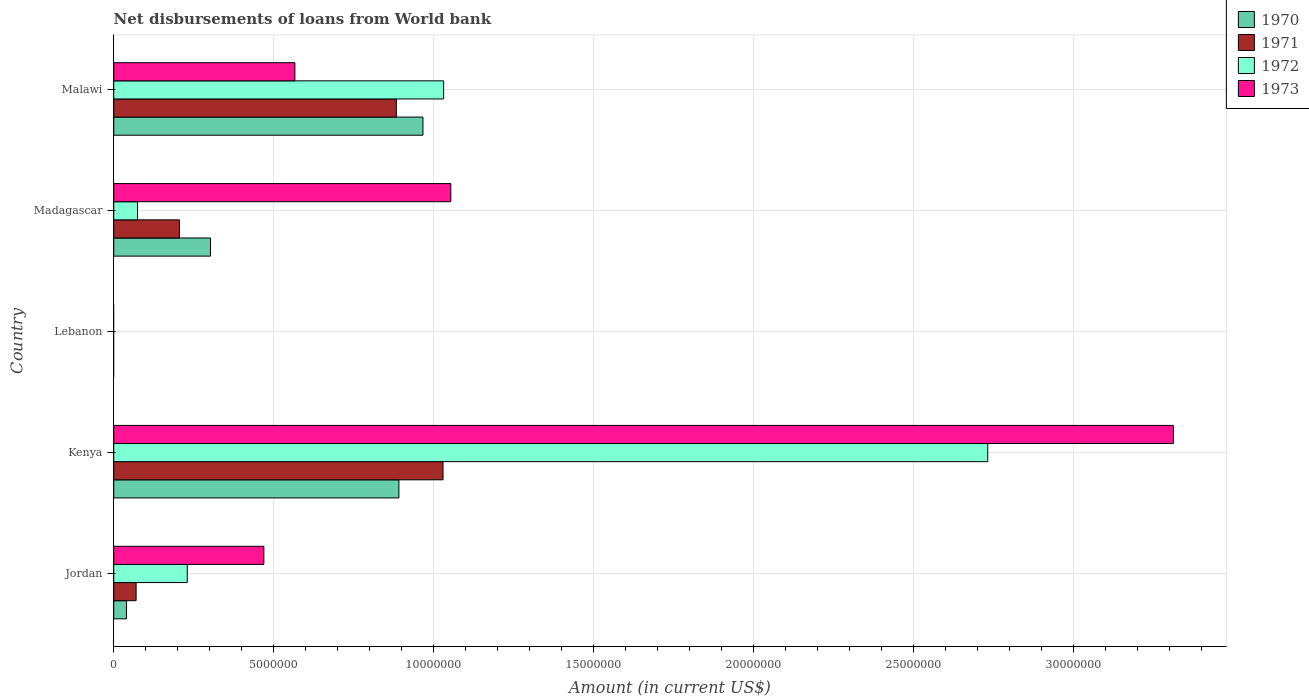How many different coloured bars are there?
Give a very brief answer. 4. How many bars are there on the 5th tick from the bottom?
Provide a succinct answer. 4. What is the label of the 1st group of bars from the top?
Offer a terse response. Malawi. What is the amount of loan disbursed from World Bank in 1971 in Madagascar?
Offer a terse response. 2.05e+06. Across all countries, what is the maximum amount of loan disbursed from World Bank in 1970?
Provide a succinct answer. 9.66e+06. In which country was the amount of loan disbursed from World Bank in 1973 maximum?
Keep it short and to the point. Kenya. What is the total amount of loan disbursed from World Bank in 1970 in the graph?
Offer a terse response. 2.20e+07. What is the difference between the amount of loan disbursed from World Bank in 1970 in Kenya and that in Madagascar?
Offer a terse response. 5.89e+06. What is the difference between the amount of loan disbursed from World Bank in 1973 in Kenya and the amount of loan disbursed from World Bank in 1970 in Madagascar?
Offer a terse response. 3.01e+07. What is the average amount of loan disbursed from World Bank in 1973 per country?
Your answer should be compact. 1.08e+07. What is the difference between the amount of loan disbursed from World Bank in 1970 and amount of loan disbursed from World Bank in 1971 in Kenya?
Provide a short and direct response. -1.38e+06. What is the ratio of the amount of loan disbursed from World Bank in 1973 in Jordan to that in Kenya?
Provide a succinct answer. 0.14. Is the amount of loan disbursed from World Bank in 1973 in Jordan less than that in Madagascar?
Ensure brevity in your answer.  Yes. What is the difference between the highest and the second highest amount of loan disbursed from World Bank in 1971?
Your answer should be very brief. 1.46e+06. What is the difference between the highest and the lowest amount of loan disbursed from World Bank in 1973?
Your answer should be compact. 3.31e+07. Is the sum of the amount of loan disbursed from World Bank in 1972 in Jordan and Malawi greater than the maximum amount of loan disbursed from World Bank in 1971 across all countries?
Offer a very short reply. Yes. Is it the case that in every country, the sum of the amount of loan disbursed from World Bank in 1971 and amount of loan disbursed from World Bank in 1973 is greater than the amount of loan disbursed from World Bank in 1972?
Make the answer very short. No. How many bars are there?
Give a very brief answer. 16. What is the difference between two consecutive major ticks on the X-axis?
Your response must be concise. 5.00e+06. Are the values on the major ticks of X-axis written in scientific E-notation?
Offer a very short reply. No. Does the graph contain grids?
Give a very brief answer. Yes. Where does the legend appear in the graph?
Your answer should be compact. Top right. How many legend labels are there?
Ensure brevity in your answer.  4. What is the title of the graph?
Offer a terse response. Net disbursements of loans from World bank. Does "2004" appear as one of the legend labels in the graph?
Your answer should be very brief. No. What is the label or title of the X-axis?
Provide a short and direct response. Amount (in current US$). What is the Amount (in current US$) in 1970 in Jordan?
Your answer should be compact. 3.99e+05. What is the Amount (in current US$) in 1971 in Jordan?
Offer a very short reply. 6.99e+05. What is the Amount (in current US$) of 1972 in Jordan?
Offer a very short reply. 2.30e+06. What is the Amount (in current US$) of 1973 in Jordan?
Ensure brevity in your answer.  4.69e+06. What is the Amount (in current US$) of 1970 in Kenya?
Your response must be concise. 8.91e+06. What is the Amount (in current US$) in 1971 in Kenya?
Offer a very short reply. 1.03e+07. What is the Amount (in current US$) in 1972 in Kenya?
Provide a succinct answer. 2.73e+07. What is the Amount (in current US$) of 1973 in Kenya?
Your answer should be compact. 3.31e+07. What is the Amount (in current US$) in 1971 in Lebanon?
Your answer should be compact. 0. What is the Amount (in current US$) in 1972 in Lebanon?
Offer a terse response. 0. What is the Amount (in current US$) of 1970 in Madagascar?
Your response must be concise. 3.02e+06. What is the Amount (in current US$) in 1971 in Madagascar?
Your response must be concise. 2.05e+06. What is the Amount (in current US$) of 1972 in Madagascar?
Your response must be concise. 7.44e+05. What is the Amount (in current US$) of 1973 in Madagascar?
Offer a very short reply. 1.05e+07. What is the Amount (in current US$) in 1970 in Malawi?
Provide a short and direct response. 9.66e+06. What is the Amount (in current US$) of 1971 in Malawi?
Make the answer very short. 8.83e+06. What is the Amount (in current US$) of 1972 in Malawi?
Your response must be concise. 1.03e+07. What is the Amount (in current US$) of 1973 in Malawi?
Provide a short and direct response. 5.66e+06. Across all countries, what is the maximum Amount (in current US$) of 1970?
Provide a short and direct response. 9.66e+06. Across all countries, what is the maximum Amount (in current US$) in 1971?
Your answer should be very brief. 1.03e+07. Across all countries, what is the maximum Amount (in current US$) in 1972?
Make the answer very short. 2.73e+07. Across all countries, what is the maximum Amount (in current US$) of 1973?
Keep it short and to the point. 3.31e+07. What is the total Amount (in current US$) of 1970 in the graph?
Your answer should be very brief. 2.20e+07. What is the total Amount (in current US$) in 1971 in the graph?
Offer a terse response. 2.19e+07. What is the total Amount (in current US$) of 1972 in the graph?
Make the answer very short. 4.07e+07. What is the total Amount (in current US$) in 1973 in the graph?
Your answer should be compact. 5.40e+07. What is the difference between the Amount (in current US$) of 1970 in Jordan and that in Kenya?
Provide a succinct answer. -8.51e+06. What is the difference between the Amount (in current US$) of 1971 in Jordan and that in Kenya?
Make the answer very short. -9.59e+06. What is the difference between the Amount (in current US$) of 1972 in Jordan and that in Kenya?
Your answer should be compact. -2.50e+07. What is the difference between the Amount (in current US$) in 1973 in Jordan and that in Kenya?
Offer a very short reply. -2.84e+07. What is the difference between the Amount (in current US$) in 1970 in Jordan and that in Madagascar?
Make the answer very short. -2.62e+06. What is the difference between the Amount (in current US$) of 1971 in Jordan and that in Madagascar?
Make the answer very short. -1.35e+06. What is the difference between the Amount (in current US$) of 1972 in Jordan and that in Madagascar?
Give a very brief answer. 1.55e+06. What is the difference between the Amount (in current US$) in 1973 in Jordan and that in Madagascar?
Make the answer very short. -5.84e+06. What is the difference between the Amount (in current US$) in 1970 in Jordan and that in Malawi?
Your response must be concise. -9.26e+06. What is the difference between the Amount (in current US$) of 1971 in Jordan and that in Malawi?
Make the answer very short. -8.13e+06. What is the difference between the Amount (in current US$) in 1972 in Jordan and that in Malawi?
Provide a short and direct response. -8.01e+06. What is the difference between the Amount (in current US$) in 1973 in Jordan and that in Malawi?
Your response must be concise. -9.69e+05. What is the difference between the Amount (in current US$) in 1970 in Kenya and that in Madagascar?
Your answer should be compact. 5.89e+06. What is the difference between the Amount (in current US$) of 1971 in Kenya and that in Madagascar?
Your answer should be very brief. 8.24e+06. What is the difference between the Amount (in current US$) in 1972 in Kenya and that in Madagascar?
Your response must be concise. 2.66e+07. What is the difference between the Amount (in current US$) in 1973 in Kenya and that in Madagascar?
Make the answer very short. 2.26e+07. What is the difference between the Amount (in current US$) of 1970 in Kenya and that in Malawi?
Your answer should be very brief. -7.51e+05. What is the difference between the Amount (in current US$) in 1971 in Kenya and that in Malawi?
Offer a terse response. 1.46e+06. What is the difference between the Amount (in current US$) of 1972 in Kenya and that in Malawi?
Your response must be concise. 1.70e+07. What is the difference between the Amount (in current US$) of 1973 in Kenya and that in Malawi?
Your answer should be compact. 2.74e+07. What is the difference between the Amount (in current US$) in 1970 in Madagascar and that in Malawi?
Your response must be concise. -6.64e+06. What is the difference between the Amount (in current US$) of 1971 in Madagascar and that in Malawi?
Provide a succinct answer. -6.78e+06. What is the difference between the Amount (in current US$) of 1972 in Madagascar and that in Malawi?
Offer a very short reply. -9.56e+06. What is the difference between the Amount (in current US$) in 1973 in Madagascar and that in Malawi?
Make the answer very short. 4.87e+06. What is the difference between the Amount (in current US$) in 1970 in Jordan and the Amount (in current US$) in 1971 in Kenya?
Offer a very short reply. -9.89e+06. What is the difference between the Amount (in current US$) in 1970 in Jordan and the Amount (in current US$) in 1972 in Kenya?
Provide a succinct answer. -2.69e+07. What is the difference between the Amount (in current US$) in 1970 in Jordan and the Amount (in current US$) in 1973 in Kenya?
Your answer should be very brief. -3.27e+07. What is the difference between the Amount (in current US$) of 1971 in Jordan and the Amount (in current US$) of 1972 in Kenya?
Make the answer very short. -2.66e+07. What is the difference between the Amount (in current US$) of 1971 in Jordan and the Amount (in current US$) of 1973 in Kenya?
Provide a short and direct response. -3.24e+07. What is the difference between the Amount (in current US$) in 1972 in Jordan and the Amount (in current US$) in 1973 in Kenya?
Provide a succinct answer. -3.08e+07. What is the difference between the Amount (in current US$) of 1970 in Jordan and the Amount (in current US$) of 1971 in Madagascar?
Your response must be concise. -1.65e+06. What is the difference between the Amount (in current US$) of 1970 in Jordan and the Amount (in current US$) of 1972 in Madagascar?
Offer a terse response. -3.45e+05. What is the difference between the Amount (in current US$) in 1970 in Jordan and the Amount (in current US$) in 1973 in Madagascar?
Provide a succinct answer. -1.01e+07. What is the difference between the Amount (in current US$) of 1971 in Jordan and the Amount (in current US$) of 1972 in Madagascar?
Provide a succinct answer. -4.50e+04. What is the difference between the Amount (in current US$) of 1971 in Jordan and the Amount (in current US$) of 1973 in Madagascar?
Provide a succinct answer. -9.83e+06. What is the difference between the Amount (in current US$) in 1972 in Jordan and the Amount (in current US$) in 1973 in Madagascar?
Make the answer very short. -8.24e+06. What is the difference between the Amount (in current US$) of 1970 in Jordan and the Amount (in current US$) of 1971 in Malawi?
Give a very brief answer. -8.43e+06. What is the difference between the Amount (in current US$) of 1970 in Jordan and the Amount (in current US$) of 1972 in Malawi?
Provide a succinct answer. -9.91e+06. What is the difference between the Amount (in current US$) in 1970 in Jordan and the Amount (in current US$) in 1973 in Malawi?
Ensure brevity in your answer.  -5.26e+06. What is the difference between the Amount (in current US$) in 1971 in Jordan and the Amount (in current US$) in 1972 in Malawi?
Provide a short and direct response. -9.61e+06. What is the difference between the Amount (in current US$) in 1971 in Jordan and the Amount (in current US$) in 1973 in Malawi?
Provide a short and direct response. -4.96e+06. What is the difference between the Amount (in current US$) of 1972 in Jordan and the Amount (in current US$) of 1973 in Malawi?
Provide a short and direct response. -3.36e+06. What is the difference between the Amount (in current US$) of 1970 in Kenya and the Amount (in current US$) of 1971 in Madagascar?
Provide a short and direct response. 6.86e+06. What is the difference between the Amount (in current US$) in 1970 in Kenya and the Amount (in current US$) in 1972 in Madagascar?
Offer a terse response. 8.17e+06. What is the difference between the Amount (in current US$) in 1970 in Kenya and the Amount (in current US$) in 1973 in Madagascar?
Your response must be concise. -1.62e+06. What is the difference between the Amount (in current US$) in 1971 in Kenya and the Amount (in current US$) in 1972 in Madagascar?
Your answer should be very brief. 9.54e+06. What is the difference between the Amount (in current US$) of 1971 in Kenya and the Amount (in current US$) of 1973 in Madagascar?
Your answer should be very brief. -2.44e+05. What is the difference between the Amount (in current US$) of 1972 in Kenya and the Amount (in current US$) of 1973 in Madagascar?
Provide a succinct answer. 1.68e+07. What is the difference between the Amount (in current US$) of 1970 in Kenya and the Amount (in current US$) of 1972 in Malawi?
Ensure brevity in your answer.  -1.40e+06. What is the difference between the Amount (in current US$) of 1970 in Kenya and the Amount (in current US$) of 1973 in Malawi?
Your answer should be very brief. 3.25e+06. What is the difference between the Amount (in current US$) in 1971 in Kenya and the Amount (in current US$) in 1972 in Malawi?
Provide a succinct answer. -1.90e+04. What is the difference between the Amount (in current US$) in 1971 in Kenya and the Amount (in current US$) in 1973 in Malawi?
Provide a succinct answer. 4.63e+06. What is the difference between the Amount (in current US$) in 1972 in Kenya and the Amount (in current US$) in 1973 in Malawi?
Offer a very short reply. 2.16e+07. What is the difference between the Amount (in current US$) of 1970 in Madagascar and the Amount (in current US$) of 1971 in Malawi?
Ensure brevity in your answer.  -5.81e+06. What is the difference between the Amount (in current US$) in 1970 in Madagascar and the Amount (in current US$) in 1972 in Malawi?
Offer a terse response. -7.28e+06. What is the difference between the Amount (in current US$) of 1970 in Madagascar and the Amount (in current US$) of 1973 in Malawi?
Ensure brevity in your answer.  -2.64e+06. What is the difference between the Amount (in current US$) of 1971 in Madagascar and the Amount (in current US$) of 1972 in Malawi?
Make the answer very short. -8.25e+06. What is the difference between the Amount (in current US$) in 1971 in Madagascar and the Amount (in current US$) in 1973 in Malawi?
Offer a very short reply. -3.61e+06. What is the difference between the Amount (in current US$) of 1972 in Madagascar and the Amount (in current US$) of 1973 in Malawi?
Your response must be concise. -4.92e+06. What is the average Amount (in current US$) of 1970 per country?
Your answer should be very brief. 4.40e+06. What is the average Amount (in current US$) in 1971 per country?
Make the answer very short. 4.37e+06. What is the average Amount (in current US$) in 1972 per country?
Give a very brief answer. 8.13e+06. What is the average Amount (in current US$) in 1973 per country?
Offer a terse response. 1.08e+07. What is the difference between the Amount (in current US$) of 1970 and Amount (in current US$) of 1972 in Jordan?
Give a very brief answer. -1.90e+06. What is the difference between the Amount (in current US$) of 1970 and Amount (in current US$) of 1973 in Jordan?
Your answer should be very brief. -4.29e+06. What is the difference between the Amount (in current US$) of 1971 and Amount (in current US$) of 1972 in Jordan?
Provide a short and direct response. -1.60e+06. What is the difference between the Amount (in current US$) of 1971 and Amount (in current US$) of 1973 in Jordan?
Your response must be concise. -3.99e+06. What is the difference between the Amount (in current US$) of 1972 and Amount (in current US$) of 1973 in Jordan?
Make the answer very short. -2.39e+06. What is the difference between the Amount (in current US$) of 1970 and Amount (in current US$) of 1971 in Kenya?
Keep it short and to the point. -1.38e+06. What is the difference between the Amount (in current US$) in 1970 and Amount (in current US$) in 1972 in Kenya?
Make the answer very short. -1.84e+07. What is the difference between the Amount (in current US$) of 1970 and Amount (in current US$) of 1973 in Kenya?
Give a very brief answer. -2.42e+07. What is the difference between the Amount (in current US$) of 1971 and Amount (in current US$) of 1972 in Kenya?
Give a very brief answer. -1.70e+07. What is the difference between the Amount (in current US$) in 1971 and Amount (in current US$) in 1973 in Kenya?
Offer a terse response. -2.28e+07. What is the difference between the Amount (in current US$) in 1972 and Amount (in current US$) in 1973 in Kenya?
Offer a very short reply. -5.80e+06. What is the difference between the Amount (in current US$) in 1970 and Amount (in current US$) in 1971 in Madagascar?
Your response must be concise. 9.70e+05. What is the difference between the Amount (in current US$) of 1970 and Amount (in current US$) of 1972 in Madagascar?
Keep it short and to the point. 2.28e+06. What is the difference between the Amount (in current US$) in 1970 and Amount (in current US$) in 1973 in Madagascar?
Your response must be concise. -7.51e+06. What is the difference between the Amount (in current US$) of 1971 and Amount (in current US$) of 1972 in Madagascar?
Offer a very short reply. 1.31e+06. What is the difference between the Amount (in current US$) of 1971 and Amount (in current US$) of 1973 in Madagascar?
Your response must be concise. -8.48e+06. What is the difference between the Amount (in current US$) of 1972 and Amount (in current US$) of 1973 in Madagascar?
Ensure brevity in your answer.  -9.79e+06. What is the difference between the Amount (in current US$) in 1970 and Amount (in current US$) in 1971 in Malawi?
Your answer should be very brief. 8.31e+05. What is the difference between the Amount (in current US$) of 1970 and Amount (in current US$) of 1972 in Malawi?
Make the answer very short. -6.46e+05. What is the difference between the Amount (in current US$) in 1970 and Amount (in current US$) in 1973 in Malawi?
Ensure brevity in your answer.  4.00e+06. What is the difference between the Amount (in current US$) in 1971 and Amount (in current US$) in 1972 in Malawi?
Keep it short and to the point. -1.48e+06. What is the difference between the Amount (in current US$) in 1971 and Amount (in current US$) in 1973 in Malawi?
Give a very brief answer. 3.17e+06. What is the difference between the Amount (in current US$) of 1972 and Amount (in current US$) of 1973 in Malawi?
Make the answer very short. 4.65e+06. What is the ratio of the Amount (in current US$) in 1970 in Jordan to that in Kenya?
Your answer should be very brief. 0.04. What is the ratio of the Amount (in current US$) of 1971 in Jordan to that in Kenya?
Make the answer very short. 0.07. What is the ratio of the Amount (in current US$) of 1972 in Jordan to that in Kenya?
Offer a terse response. 0.08. What is the ratio of the Amount (in current US$) in 1973 in Jordan to that in Kenya?
Offer a very short reply. 0.14. What is the ratio of the Amount (in current US$) in 1970 in Jordan to that in Madagascar?
Your answer should be compact. 0.13. What is the ratio of the Amount (in current US$) in 1971 in Jordan to that in Madagascar?
Your answer should be compact. 0.34. What is the ratio of the Amount (in current US$) in 1972 in Jordan to that in Madagascar?
Ensure brevity in your answer.  3.09. What is the ratio of the Amount (in current US$) in 1973 in Jordan to that in Madagascar?
Ensure brevity in your answer.  0.45. What is the ratio of the Amount (in current US$) in 1970 in Jordan to that in Malawi?
Ensure brevity in your answer.  0.04. What is the ratio of the Amount (in current US$) of 1971 in Jordan to that in Malawi?
Your answer should be very brief. 0.08. What is the ratio of the Amount (in current US$) in 1972 in Jordan to that in Malawi?
Your answer should be compact. 0.22. What is the ratio of the Amount (in current US$) of 1973 in Jordan to that in Malawi?
Your response must be concise. 0.83. What is the ratio of the Amount (in current US$) in 1970 in Kenya to that in Madagascar?
Offer a terse response. 2.95. What is the ratio of the Amount (in current US$) of 1971 in Kenya to that in Madagascar?
Your answer should be compact. 5.01. What is the ratio of the Amount (in current US$) in 1972 in Kenya to that in Madagascar?
Your response must be concise. 36.7. What is the ratio of the Amount (in current US$) in 1973 in Kenya to that in Madagascar?
Offer a terse response. 3.14. What is the ratio of the Amount (in current US$) in 1970 in Kenya to that in Malawi?
Make the answer very short. 0.92. What is the ratio of the Amount (in current US$) in 1971 in Kenya to that in Malawi?
Give a very brief answer. 1.17. What is the ratio of the Amount (in current US$) of 1972 in Kenya to that in Malawi?
Give a very brief answer. 2.65. What is the ratio of the Amount (in current US$) in 1973 in Kenya to that in Malawi?
Your response must be concise. 5.85. What is the ratio of the Amount (in current US$) in 1970 in Madagascar to that in Malawi?
Offer a very short reply. 0.31. What is the ratio of the Amount (in current US$) in 1971 in Madagascar to that in Malawi?
Offer a terse response. 0.23. What is the ratio of the Amount (in current US$) of 1972 in Madagascar to that in Malawi?
Your response must be concise. 0.07. What is the ratio of the Amount (in current US$) of 1973 in Madagascar to that in Malawi?
Offer a very short reply. 1.86. What is the difference between the highest and the second highest Amount (in current US$) of 1970?
Keep it short and to the point. 7.51e+05. What is the difference between the highest and the second highest Amount (in current US$) of 1971?
Offer a very short reply. 1.46e+06. What is the difference between the highest and the second highest Amount (in current US$) of 1972?
Keep it short and to the point. 1.70e+07. What is the difference between the highest and the second highest Amount (in current US$) in 1973?
Offer a very short reply. 2.26e+07. What is the difference between the highest and the lowest Amount (in current US$) of 1970?
Ensure brevity in your answer.  9.66e+06. What is the difference between the highest and the lowest Amount (in current US$) in 1971?
Give a very brief answer. 1.03e+07. What is the difference between the highest and the lowest Amount (in current US$) in 1972?
Your response must be concise. 2.73e+07. What is the difference between the highest and the lowest Amount (in current US$) in 1973?
Make the answer very short. 3.31e+07. 